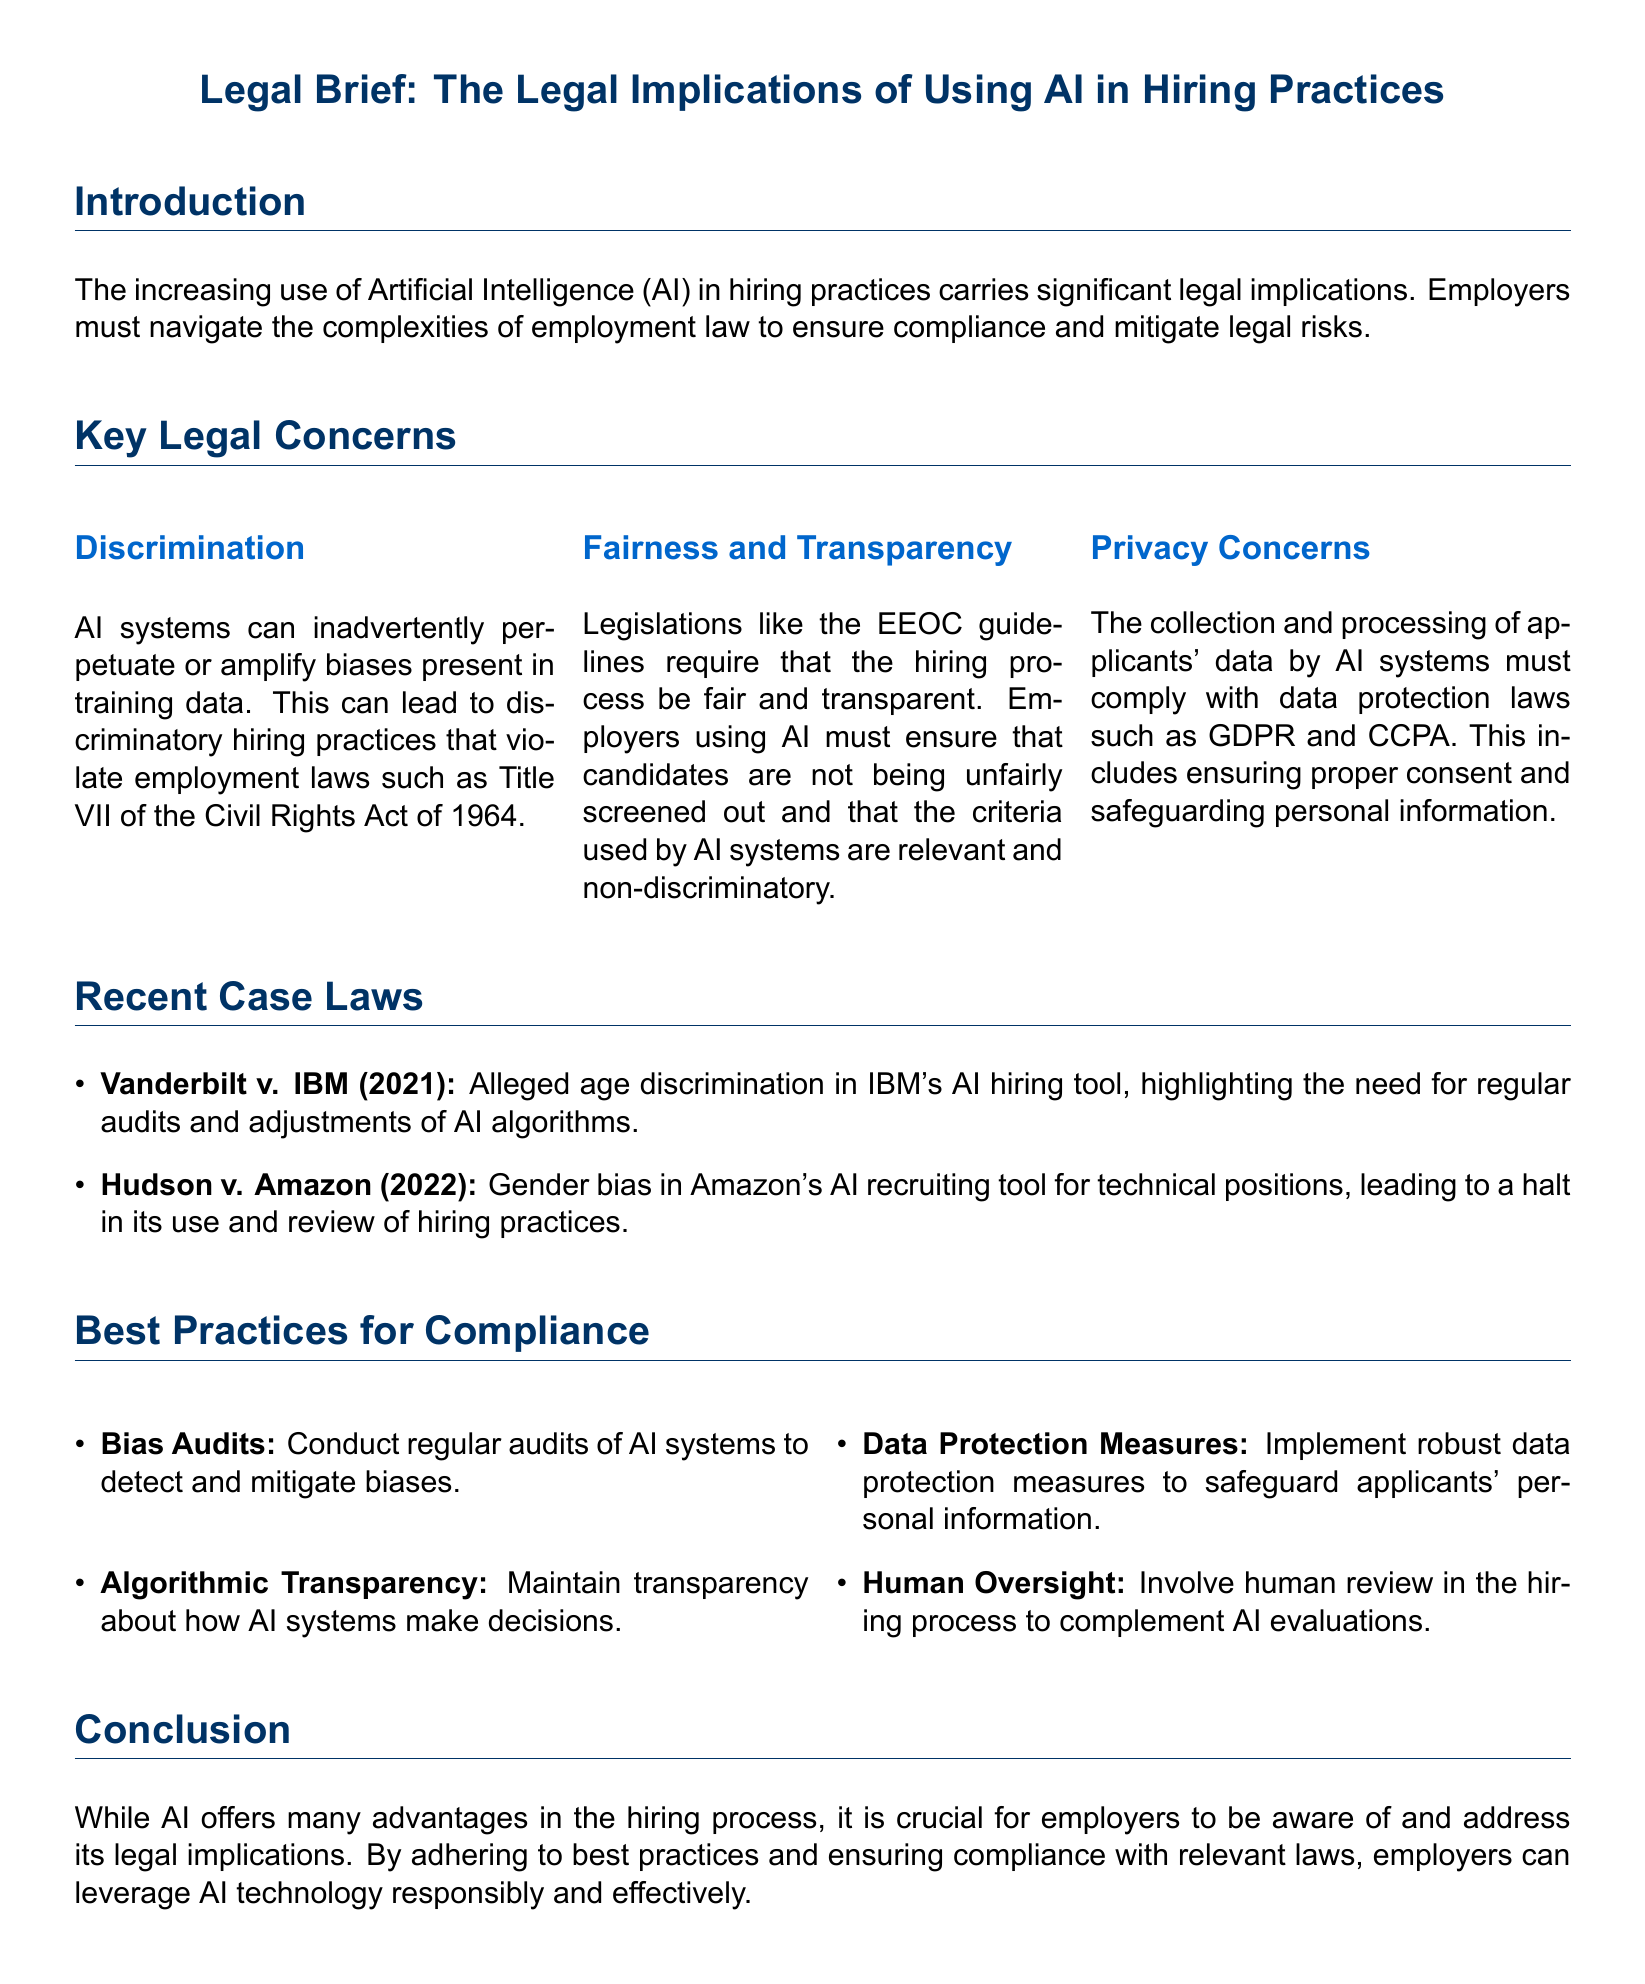What is the title of the legal brief? The title is a key heading that summarizes the document's subject matter.
Answer: Legal Brief: The Legal Implications of Using AI in Hiring Practices What are the two recent cases mentioned? The document identifies specific legal cases that illustrate the implications of AI in hiring.
Answer: Vanderbilt v. IBM and Hudson v. Amazon What is the main concern related to AI systems in hiring? The document lists several key legal concerns, highlighting the primary issue at hand.
Answer: Discrimination What year was the Hudson v. Amazon case? The date indicates when this specific legal case occurred, which is relevant for understanding its context.
Answer: 2022 What practice involves conducting regular audits of AI systems? This practice addresses the detection and mitigation of biases in AI systems.
Answer: Bias Audits Which legislation requires fairness and transparency in the hiring process? This legislation is crucial for ensuring non-discriminatory hiring practices by employers.
Answer: EEOC guidelines What kind of protection measures are essential for applicant data? This refers to the legal requirements for safeguarding personal information collected during the hiring process.
Answer: Data Protection Measures What must employers maintain about AI decision-making processes? This is about ensuring openness and clarity regarding how AI systems operate in hiring.
Answer: Algorithmic Transparency What does the conclusion suggest about the use of AI in hiring? The conclusion provides a summary of the document's stance on the responsible and compliant use of AI technology.
Answer: Crucial for employers to be aware of and address its legal implications 